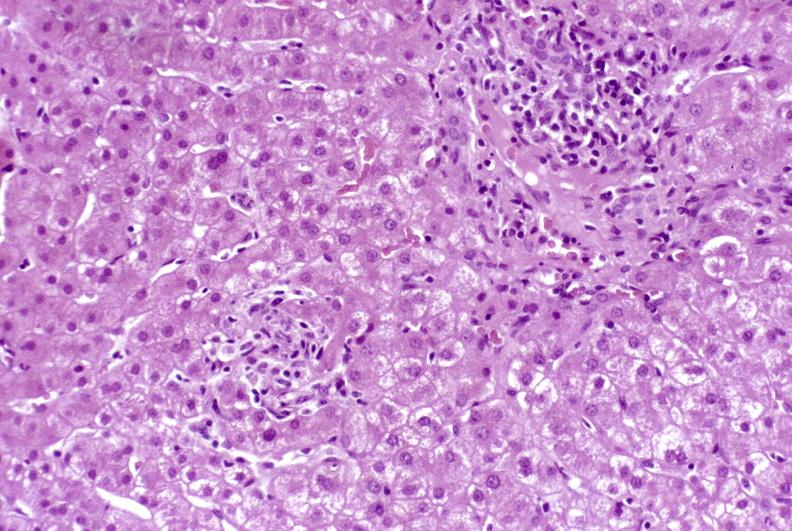s splenomegaly with cirrhosis present?
Answer the question using a single word or phrase. No 